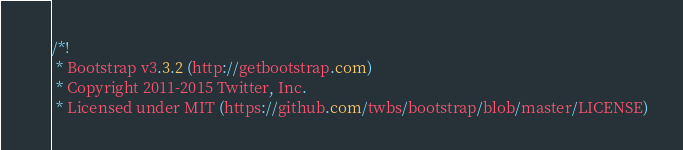<code> <loc_0><loc_0><loc_500><loc_500><_CSS_>/*!
 * Bootstrap v3.3.2 (http://getbootstrap.com)
 * Copyright 2011-2015 Twitter, Inc.
 * Licensed under MIT (https://github.com/twbs/bootstrap/blob/master/LICENSE)</code> 